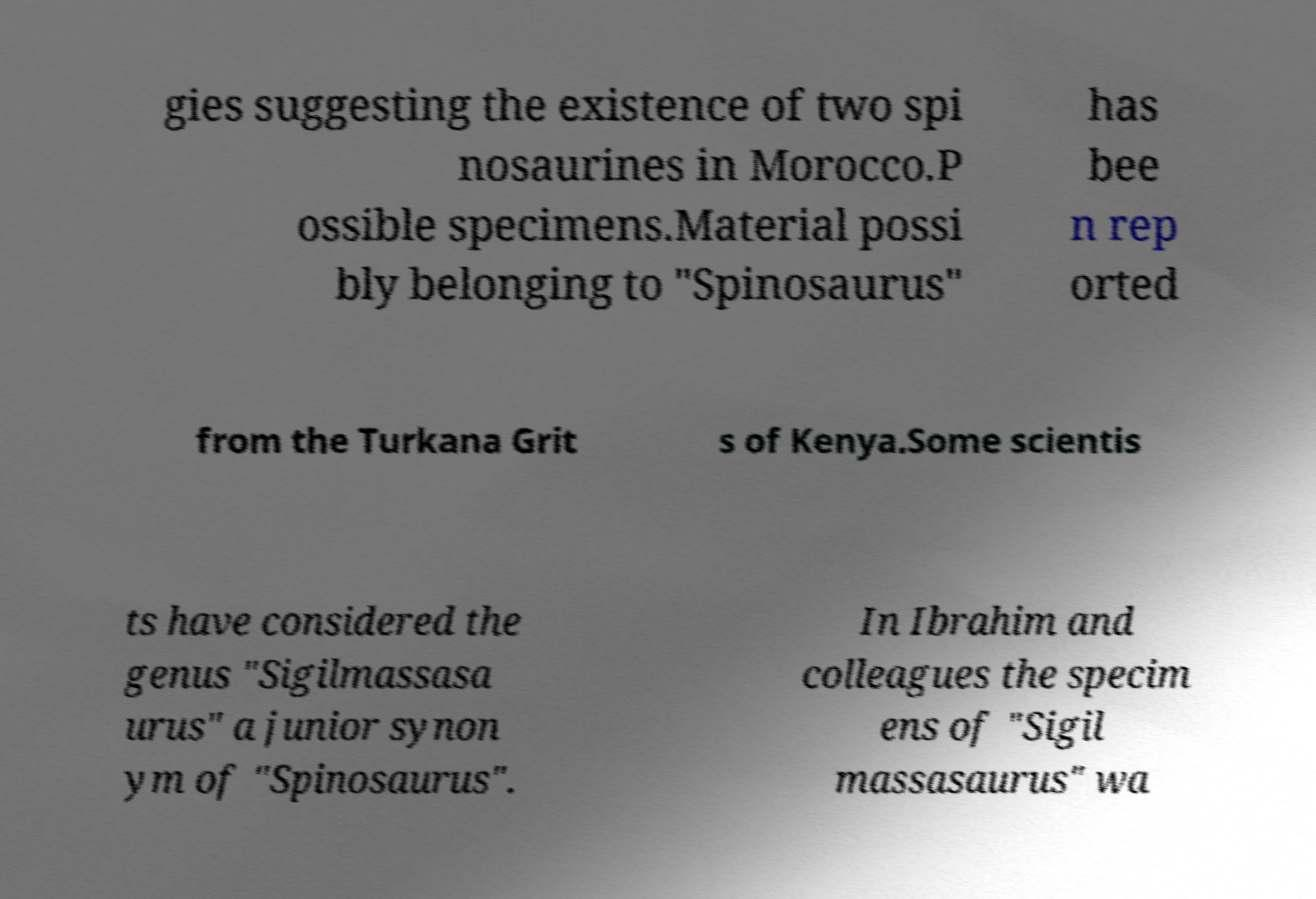Please read and relay the text visible in this image. What does it say? gies suggesting the existence of two spi nosaurines in Morocco.P ossible specimens.Material possi bly belonging to "Spinosaurus" has bee n rep orted from the Turkana Grit s of Kenya.Some scientis ts have considered the genus "Sigilmassasa urus" a junior synon ym of "Spinosaurus". In Ibrahim and colleagues the specim ens of "Sigil massasaurus" wa 